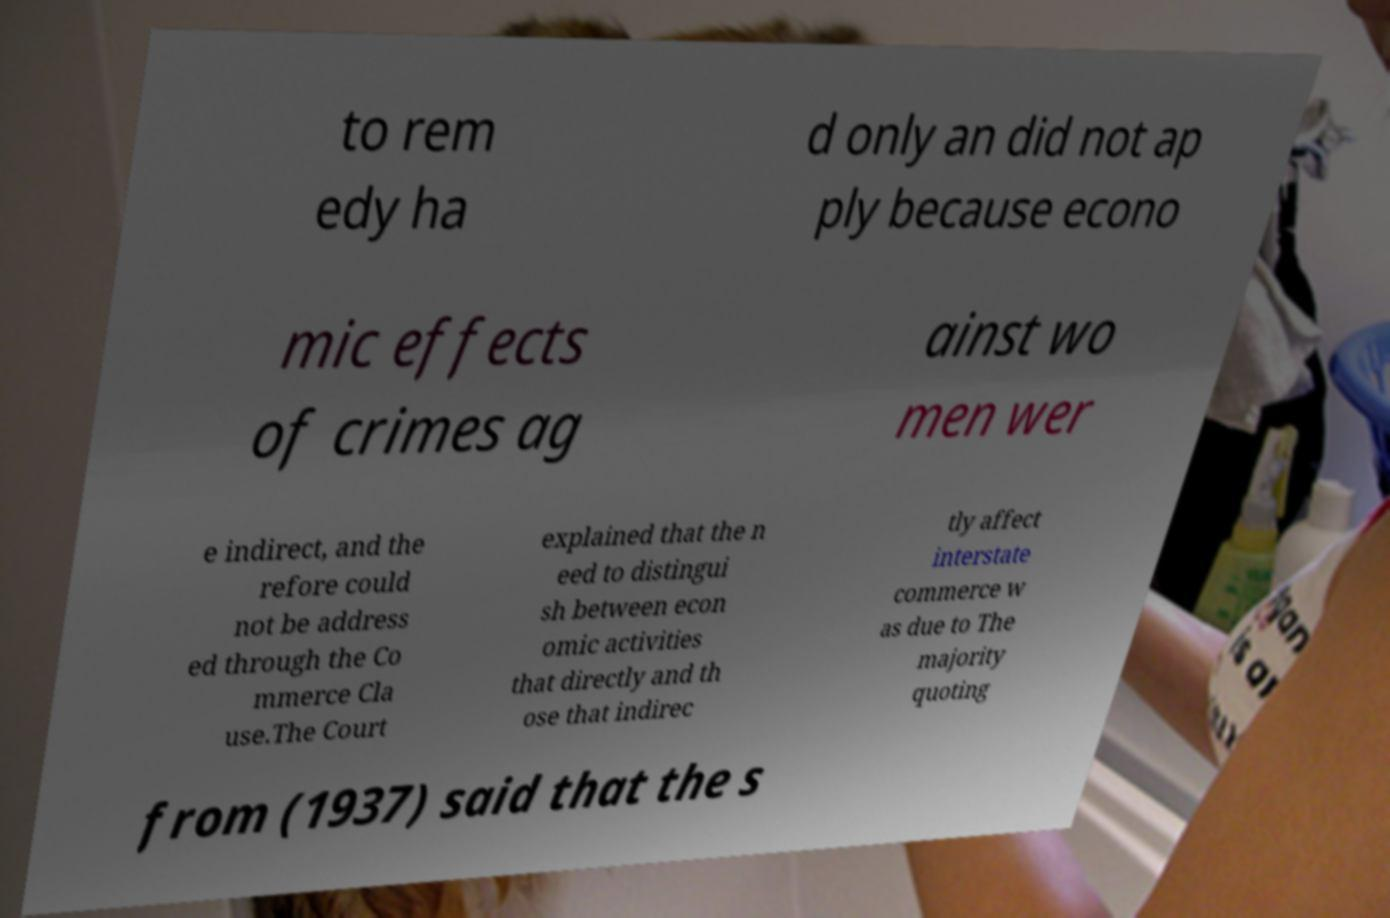Can you accurately transcribe the text from the provided image for me? to rem edy ha d only an did not ap ply because econo mic effects of crimes ag ainst wo men wer e indirect, and the refore could not be address ed through the Co mmerce Cla use.The Court explained that the n eed to distingui sh between econ omic activities that directly and th ose that indirec tly affect interstate commerce w as due to The majority quoting from (1937) said that the s 